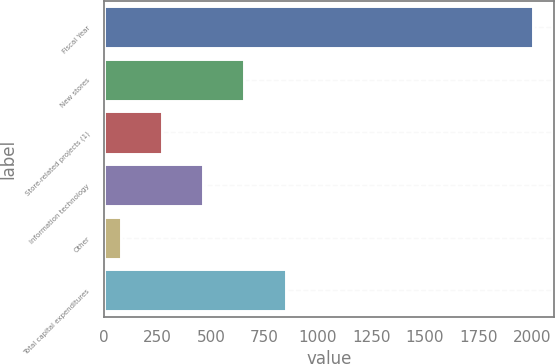Convert chart to OTSL. <chart><loc_0><loc_0><loc_500><loc_500><bar_chart><fcel>Fiscal Year<fcel>New stores<fcel>Store-related projects (1)<fcel>Information technology<fcel>Other<fcel>Total capital expenditures<nl><fcel>2004<fcel>655.8<fcel>270.6<fcel>463.2<fcel>78<fcel>848.4<nl></chart> 